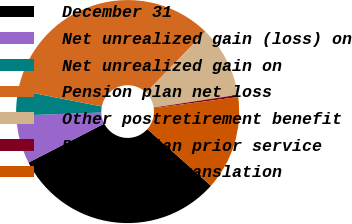<chart> <loc_0><loc_0><loc_500><loc_500><pie_chart><fcel>December 31<fcel>Net unrealized gain (loss) on<fcel>Net unrealized gain on<fcel>Pension plan net loss<fcel>Other postretirement benefit<fcel>Pension plan prior service<fcel>Cumulative translation<nl><fcel>30.86%<fcel>6.99%<fcel>3.66%<fcel>34.19%<fcel>10.32%<fcel>0.32%<fcel>13.66%<nl></chart> 